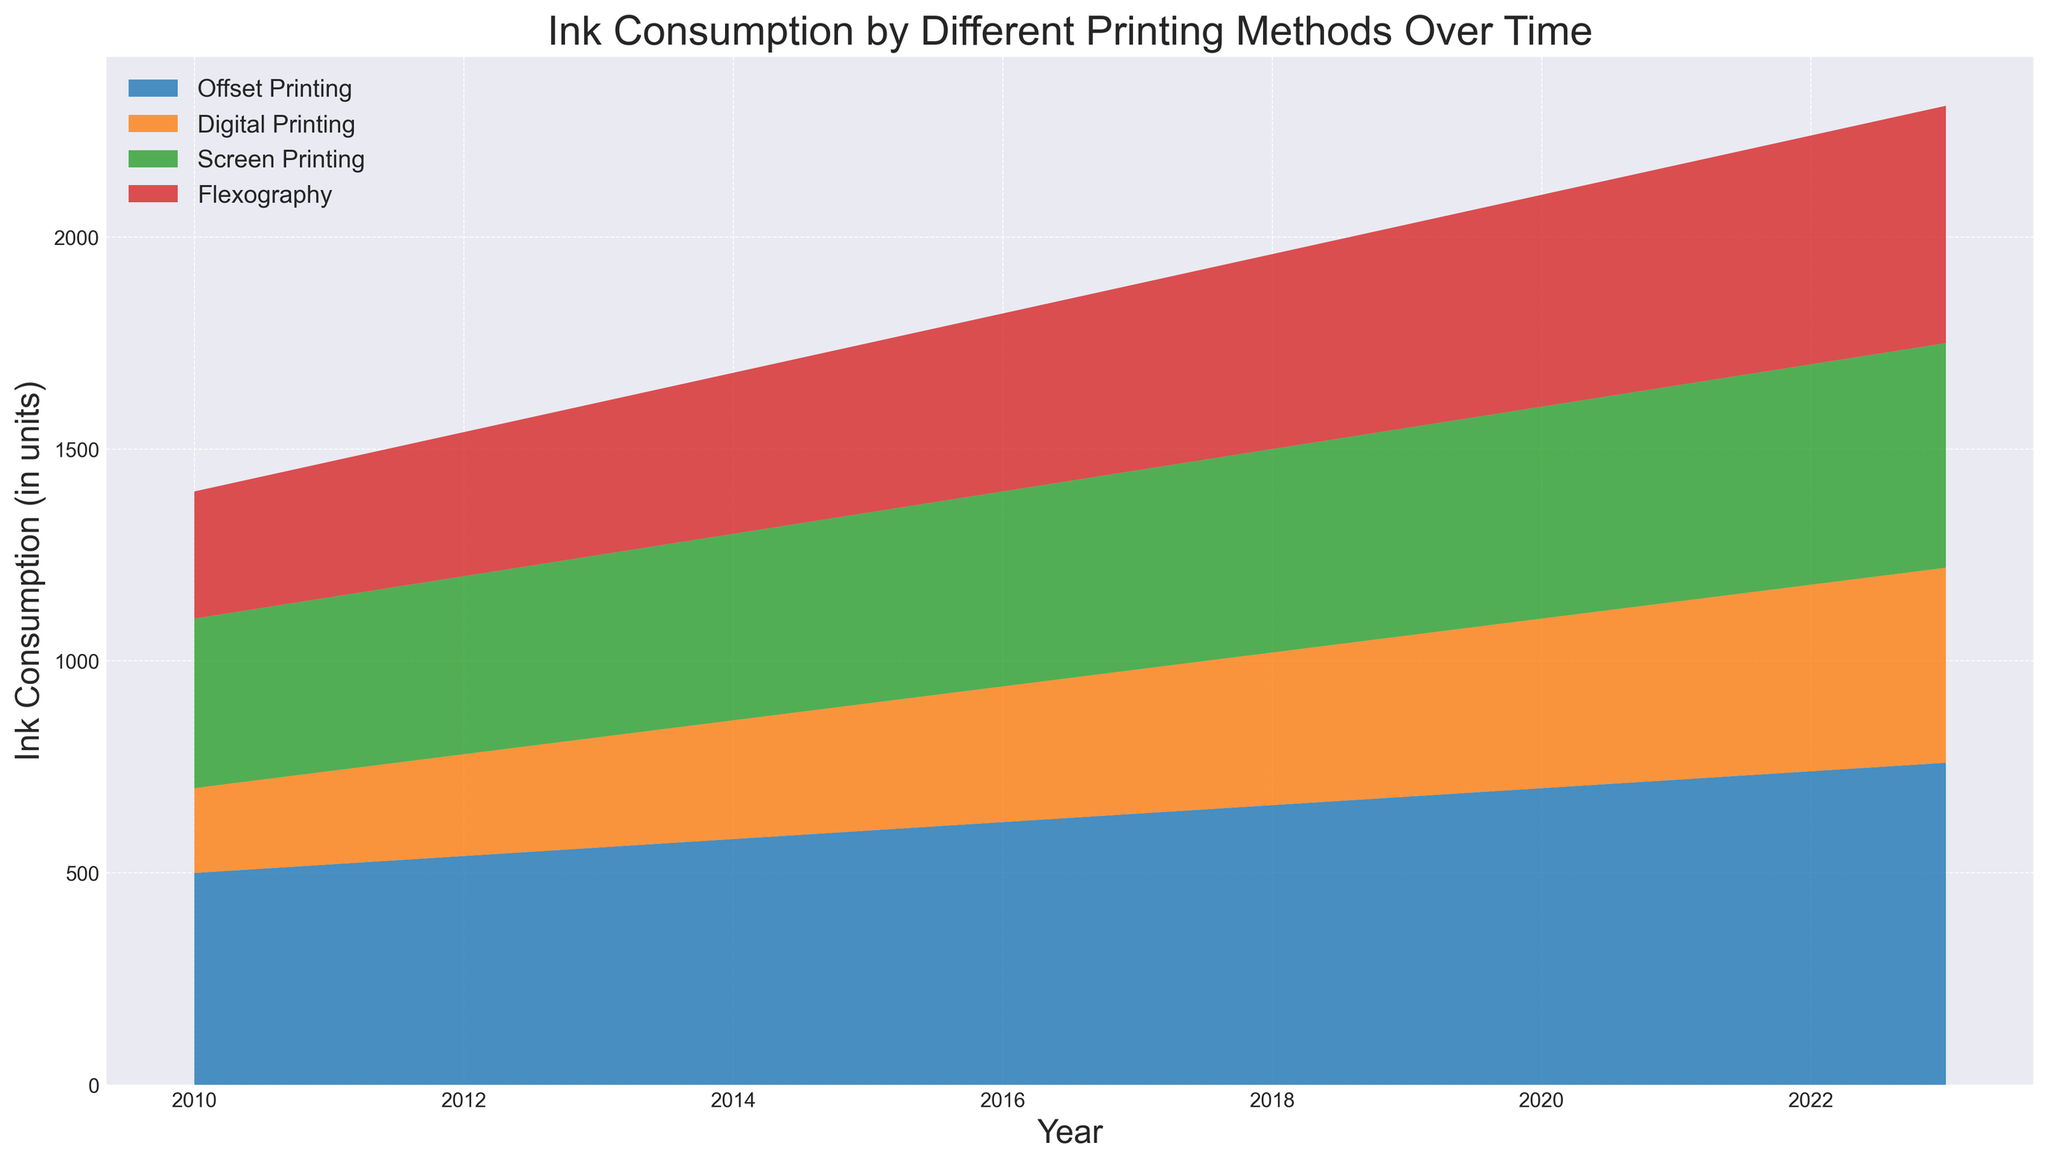What was the ink consumption for Offset Printing in 2015? To find the ink consumption for Offset Printing in 2015, locate the year 2015 on the x-axis and check the corresponding value for Offset Printing.
Answer: 600 How does the ink consumption of Digital Printing in 2020 compare to that in 2010? Compare the values of Digital Printing for the years 2020 and 2010 by locating these years on the x-axis and referencing the Digital Printing segment of the stackplot.
Answer: 2020 is higher What is the total ink consumption for all printing methods combined in 2023? Sum the values for Offset Printing, Digital Printing, Screen Printing, and Flexography for the year 2023.
Answer: 2310 Which printing method showed the greatest increase in ink consumption from 2010 to 2023? Calculate the difference in ink consumption for each printing method between 2010 and 2023 and identify the one with the largest difference.
Answer: Offset Printing What is the trend observed in Screen Printing ink consumption between 2010 and 2023? Observe the change in the area corresponding to Screen Printing from 2010 to 2023 to determine if it increases, decreases, or remains stable.
Answer: Increasing In which year was the ink consumption for Flexography greater than the combined consumption of Digital and Screen Printing? Identify the years where the value of Flexography exceeds the sum of Digital Printing and Screen Printing by comparing the respective values.
Answer: No such year How much did the ink consumption for Flexography increase from 2010 to 2023? Subtract the ink consumption for Flexography in 2010 from that in 2023 to find the increase.
Answer: 260 Which printing method had the smallest change in ink consumption from 2010 to 2023? Compare the differences in ink consumption from 2010 to 2023 for each printing method and identify the smallest difference.
Answer: Screen Printing 